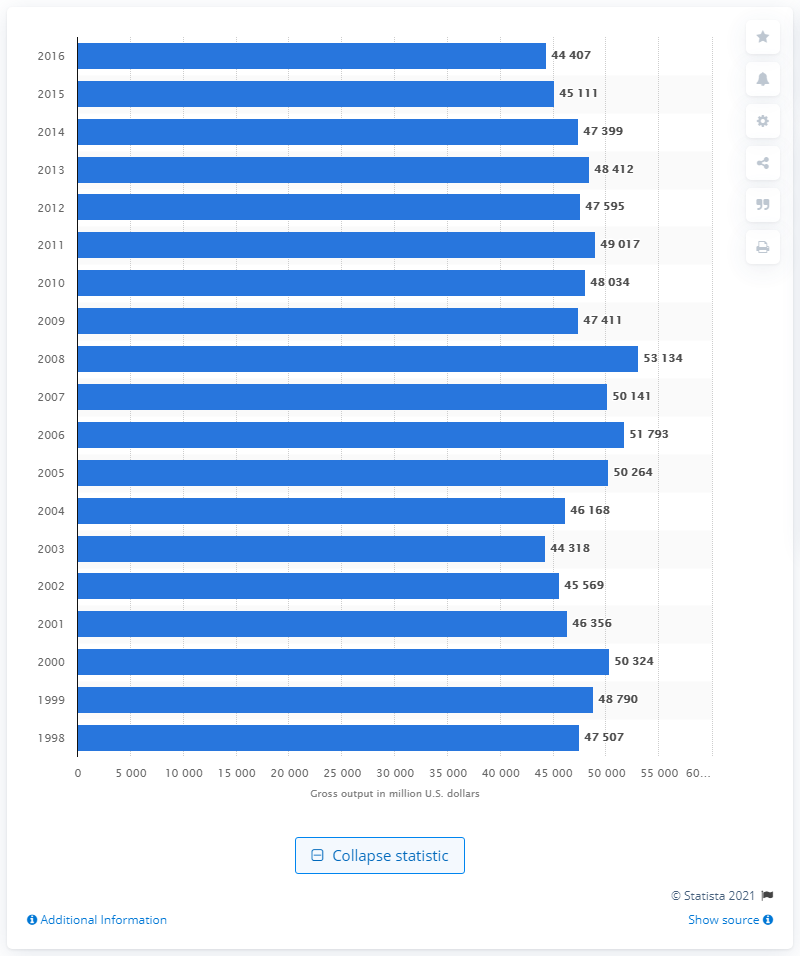Identify some key points in this picture. In 1998, the gross output of paper mills in the United States was approximately 47,399. In 2016, the gross output of paper mills in the United States was approximately 44,407 million dollars. 